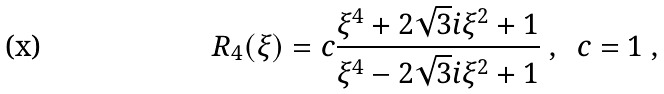Convert formula to latex. <formula><loc_0><loc_0><loc_500><loc_500>R _ { 4 } ( \xi ) = c \frac { \xi ^ { 4 } + 2 \sqrt { 3 } i \xi ^ { 2 } + 1 } { \xi ^ { 4 } - 2 \sqrt { 3 } i \xi ^ { 2 } + 1 } \ , \ \ c = 1 \ , \</formula> 